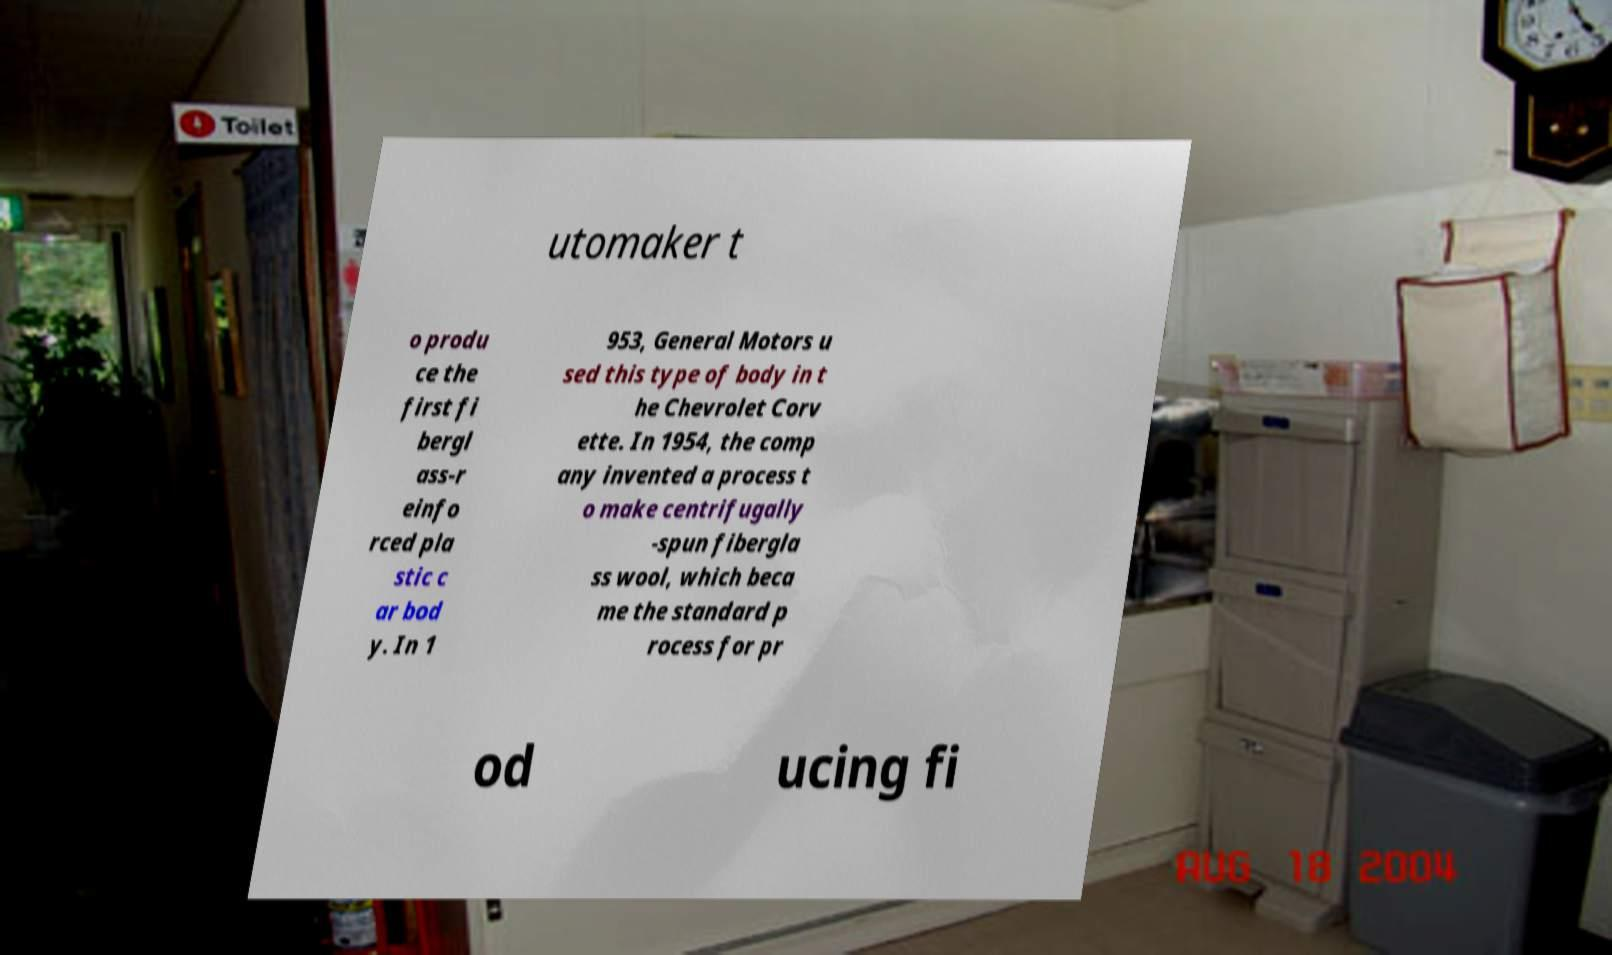For documentation purposes, I need the text within this image transcribed. Could you provide that? utomaker t o produ ce the first fi bergl ass-r einfo rced pla stic c ar bod y. In 1 953, General Motors u sed this type of body in t he Chevrolet Corv ette. In 1954, the comp any invented a process t o make centrifugally -spun fibergla ss wool, which beca me the standard p rocess for pr od ucing fi 